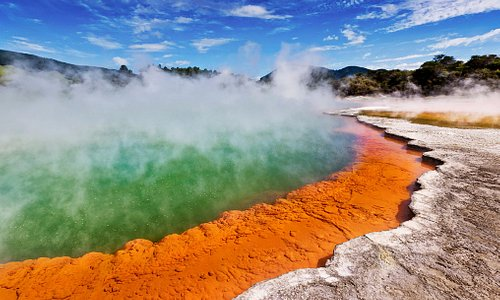What is this photo about? This image beautifully captures the Wai-O-Tapu Thermal Wonderland, a geothermal reserve in Rotorua, New Zealand, renowned for its vibrant hot springs and geothermal activity. The photograph highlights a particularly striking hot spring, characterized by its vivid green water, which gains its bright color from sulfuric minerals. The edges of the spring are encrusted with brilliant orange and red mineral deposits, creating a striking contrast. Wisps of steam rise from the warm water, adding an ethereal atmosphere to the scene. The lush greenery and rolling hills in the background suggest the rich, natural landscape of the area, which is both a popular tourist attraction and a site of significant geological research due to its volcanic features. This scene not only showcases natural beauty but also speaks to the dynamic processes of Earth's geothermal activity. 